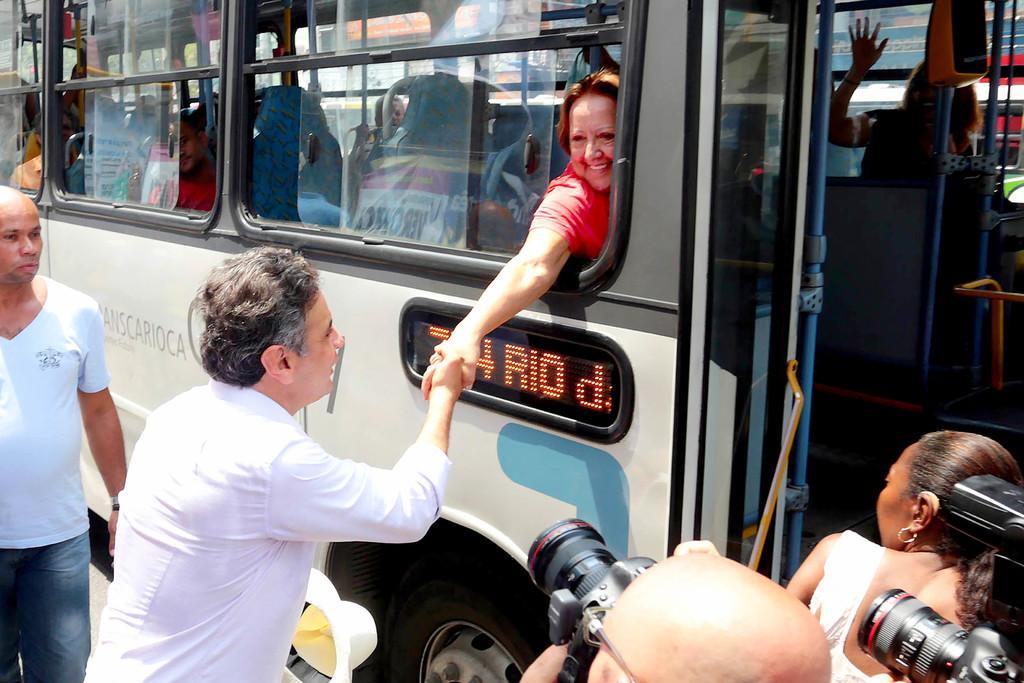Describe this image in one or two sentences. A woman is giving a shake hand to a man from a window of a bus. There is another man standing beside the bus. There are few people taking the picture of the scene happening. 